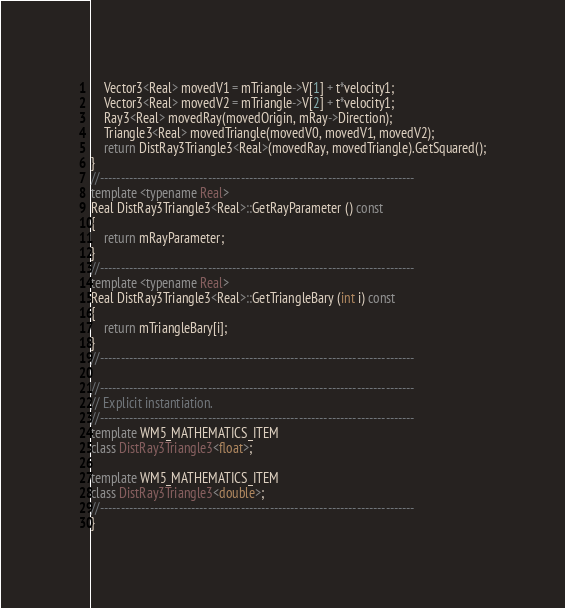<code> <loc_0><loc_0><loc_500><loc_500><_C++_>	Vector3<Real> movedV1 = mTriangle->V[1] + t*velocity1;
	Vector3<Real> movedV2 = mTriangle->V[2] + t*velocity1;
	Ray3<Real> movedRay(movedOrigin, mRay->Direction);
	Triangle3<Real> movedTriangle(movedV0, movedV1, movedV2);
	return DistRay3Triangle3<Real>(movedRay, movedTriangle).GetSquared();
}
//----------------------------------------------------------------------------
template <typename Real>
Real DistRay3Triangle3<Real>::GetRayParameter () const
{
	return mRayParameter;
}
//----------------------------------------------------------------------------
template <typename Real>
Real DistRay3Triangle3<Real>::GetTriangleBary (int i) const
{
	return mTriangleBary[i];
}
//----------------------------------------------------------------------------

//----------------------------------------------------------------------------
// Explicit instantiation.
//----------------------------------------------------------------------------
template WM5_MATHEMATICS_ITEM
class DistRay3Triangle3<float>;

template WM5_MATHEMATICS_ITEM
class DistRay3Triangle3<double>;
//----------------------------------------------------------------------------
}
</code> 